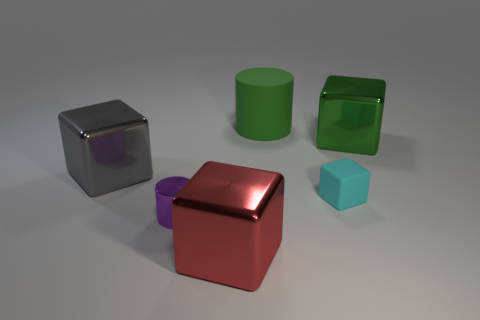There is a big metallic block that is on the right side of the big cylinder; is it the same color as the big rubber object?
Your response must be concise. Yes. How many other things are there of the same shape as the green shiny object?
Offer a terse response. 3. What number of other things are the same material as the tiny cylinder?
Make the answer very short. 3. There is a cylinder in front of the large object to the right of the cylinder that is behind the big green cube; what is its material?
Give a very brief answer. Metal. Is the tiny purple cylinder made of the same material as the big cylinder?
Keep it short and to the point. No. What number of balls are either gray shiny things or green shiny objects?
Your answer should be very brief. 0. There is a rubber object that is in front of the green shiny block; what is its color?
Make the answer very short. Cyan. How many metallic things are tiny red spheres or large objects?
Your response must be concise. 3. What is the cylinder that is to the right of the large thing in front of the tiny purple metallic cylinder made of?
Keep it short and to the point. Rubber. What is the color of the tiny metallic thing?
Provide a short and direct response. Purple. 